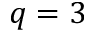<formula> <loc_0><loc_0><loc_500><loc_500>q = 3</formula> 